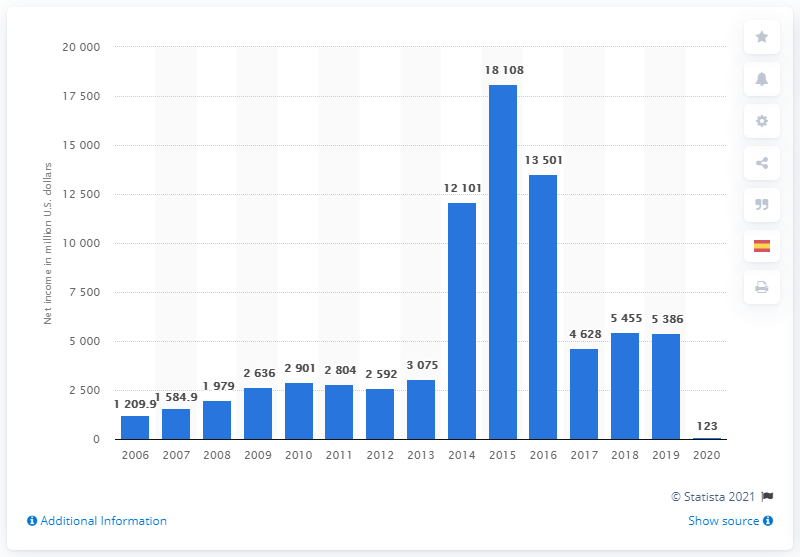Indicate a few pertinent items in this graphic. Gilead Sciences' net income in 2019 was $5,386 million. In 2019, Gilead Sciences' net income was $123 million. 